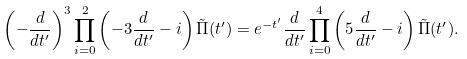<formula> <loc_0><loc_0><loc_500><loc_500>\left ( - \frac { d } { d t ^ { \prime } } \right ) ^ { 3 } \prod _ { i = 0 } ^ { 2 } \left ( - 3 \frac { d } { d t ^ { \prime } } - i \right ) \tilde { \Pi } ( t ^ { \prime } ) = e ^ { - t ^ { \prime } } \frac { d } { d t ^ { \prime } } \prod _ { i = 0 } ^ { 4 } \left ( 5 \frac { d } { d t ^ { \prime } } - i \right ) \tilde { \Pi } ( t ^ { \prime } ) .</formula> 